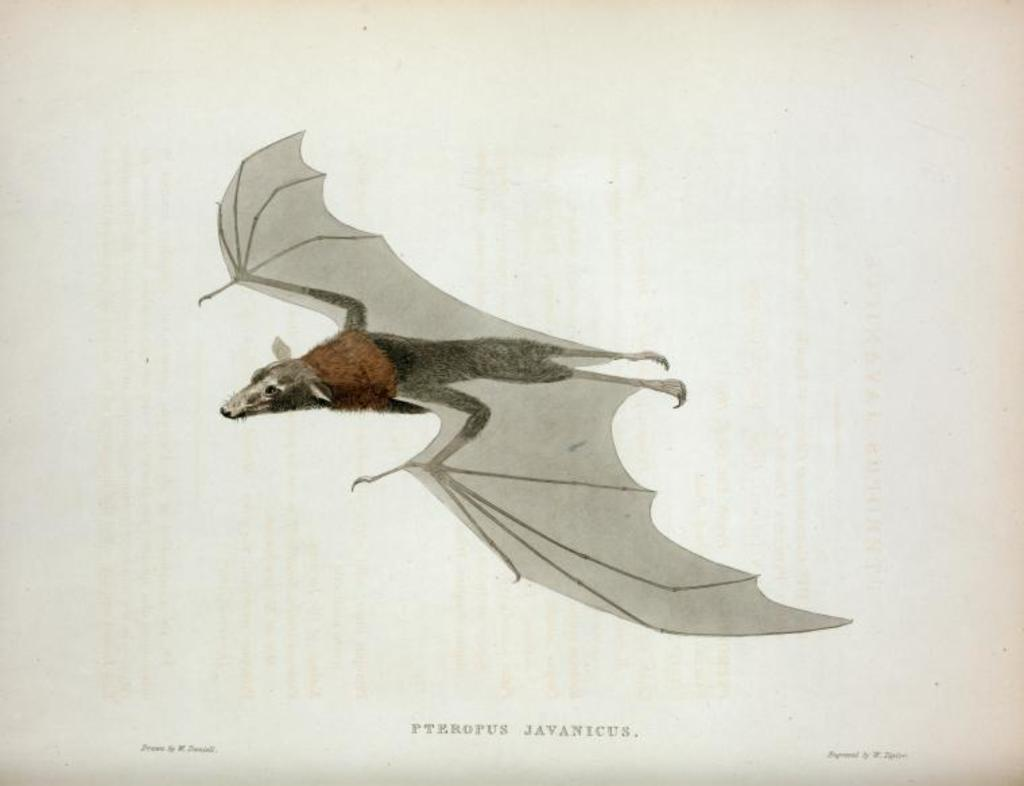What is the main subject of the image? The main subject of the image is a picture of a bat. What else can be seen at the bottom of the image? There is text at the bottom of the image. What color is the background of the image? The background of the image is white. What type of mask is being worn by the doll in the image? There is no doll or mask present in the image; it features a picture of a bat and text on a white background. 